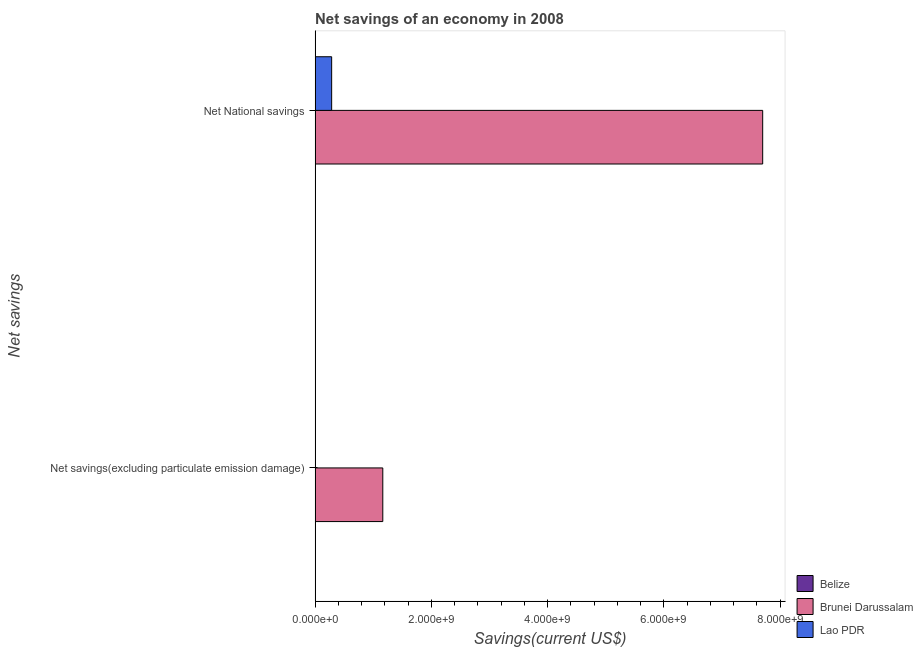How many different coloured bars are there?
Offer a very short reply. 2. Are the number of bars per tick equal to the number of legend labels?
Your answer should be very brief. No. Are the number of bars on each tick of the Y-axis equal?
Make the answer very short. No. How many bars are there on the 2nd tick from the top?
Provide a short and direct response. 1. How many bars are there on the 2nd tick from the bottom?
Offer a terse response. 2. What is the label of the 2nd group of bars from the top?
Offer a terse response. Net savings(excluding particulate emission damage). What is the net national savings in Brunei Darussalam?
Keep it short and to the point. 7.70e+09. Across all countries, what is the maximum net savings(excluding particulate emission damage)?
Provide a short and direct response. 1.16e+09. In which country was the net national savings maximum?
Provide a succinct answer. Brunei Darussalam. What is the total net savings(excluding particulate emission damage) in the graph?
Give a very brief answer. 1.16e+09. What is the difference between the net national savings in Brunei Darussalam and that in Lao PDR?
Keep it short and to the point. 7.41e+09. What is the difference between the net national savings in Belize and the net savings(excluding particulate emission damage) in Brunei Darussalam?
Keep it short and to the point. -1.16e+09. What is the average net national savings per country?
Keep it short and to the point. 2.66e+09. What is the difference between the net national savings and net savings(excluding particulate emission damage) in Brunei Darussalam?
Give a very brief answer. 6.53e+09. In how many countries, is the net savings(excluding particulate emission damage) greater than 7600000000 US$?
Ensure brevity in your answer.  0. What is the ratio of the net national savings in Brunei Darussalam to that in Lao PDR?
Your answer should be compact. 27.03. In how many countries, is the net savings(excluding particulate emission damage) greater than the average net savings(excluding particulate emission damage) taken over all countries?
Your answer should be very brief. 1. Are all the bars in the graph horizontal?
Offer a terse response. Yes. How many legend labels are there?
Give a very brief answer. 3. What is the title of the graph?
Your answer should be compact. Net savings of an economy in 2008. Does "Uganda" appear as one of the legend labels in the graph?
Keep it short and to the point. No. What is the label or title of the X-axis?
Make the answer very short. Savings(current US$). What is the label or title of the Y-axis?
Offer a terse response. Net savings. What is the Savings(current US$) of Belize in Net savings(excluding particulate emission damage)?
Provide a short and direct response. 0. What is the Savings(current US$) of Brunei Darussalam in Net savings(excluding particulate emission damage)?
Your response must be concise. 1.16e+09. What is the Savings(current US$) of Lao PDR in Net savings(excluding particulate emission damage)?
Ensure brevity in your answer.  0. What is the Savings(current US$) of Brunei Darussalam in Net National savings?
Keep it short and to the point. 7.70e+09. What is the Savings(current US$) in Lao PDR in Net National savings?
Give a very brief answer. 2.85e+08. Across all Net savings, what is the maximum Savings(current US$) in Brunei Darussalam?
Provide a short and direct response. 7.70e+09. Across all Net savings, what is the maximum Savings(current US$) of Lao PDR?
Your response must be concise. 2.85e+08. Across all Net savings, what is the minimum Savings(current US$) of Brunei Darussalam?
Ensure brevity in your answer.  1.16e+09. Across all Net savings, what is the minimum Savings(current US$) in Lao PDR?
Provide a short and direct response. 0. What is the total Savings(current US$) in Brunei Darussalam in the graph?
Your answer should be very brief. 8.86e+09. What is the total Savings(current US$) in Lao PDR in the graph?
Offer a terse response. 2.85e+08. What is the difference between the Savings(current US$) of Brunei Darussalam in Net savings(excluding particulate emission damage) and that in Net National savings?
Offer a very short reply. -6.53e+09. What is the difference between the Savings(current US$) of Brunei Darussalam in Net savings(excluding particulate emission damage) and the Savings(current US$) of Lao PDR in Net National savings?
Give a very brief answer. 8.79e+08. What is the average Savings(current US$) of Belize per Net savings?
Offer a very short reply. 0. What is the average Savings(current US$) of Brunei Darussalam per Net savings?
Ensure brevity in your answer.  4.43e+09. What is the average Savings(current US$) in Lao PDR per Net savings?
Offer a terse response. 1.42e+08. What is the difference between the Savings(current US$) in Brunei Darussalam and Savings(current US$) in Lao PDR in Net National savings?
Your answer should be compact. 7.41e+09. What is the ratio of the Savings(current US$) in Brunei Darussalam in Net savings(excluding particulate emission damage) to that in Net National savings?
Provide a short and direct response. 0.15. What is the difference between the highest and the second highest Savings(current US$) of Brunei Darussalam?
Your answer should be very brief. 6.53e+09. What is the difference between the highest and the lowest Savings(current US$) in Brunei Darussalam?
Provide a succinct answer. 6.53e+09. What is the difference between the highest and the lowest Savings(current US$) of Lao PDR?
Make the answer very short. 2.85e+08. 